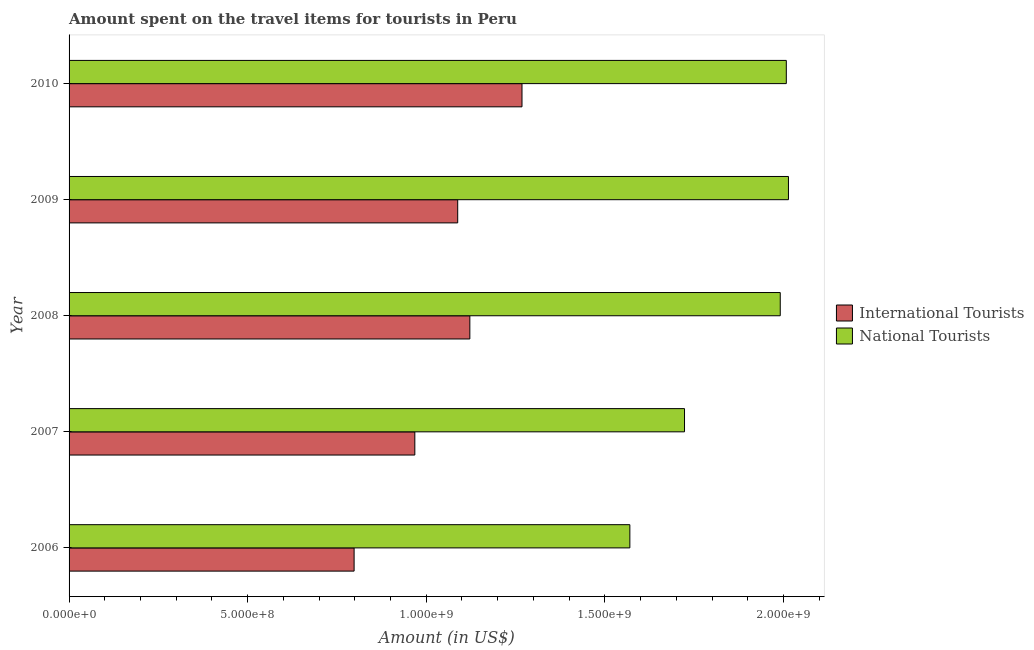How many different coloured bars are there?
Provide a short and direct response. 2. How many groups of bars are there?
Your response must be concise. 5. What is the amount spent on travel items of international tourists in 2009?
Your answer should be compact. 1.09e+09. Across all years, what is the maximum amount spent on travel items of international tourists?
Make the answer very short. 1.27e+09. Across all years, what is the minimum amount spent on travel items of national tourists?
Offer a very short reply. 1.57e+09. In which year was the amount spent on travel items of international tourists maximum?
Your response must be concise. 2010. What is the total amount spent on travel items of national tourists in the graph?
Give a very brief answer. 9.31e+09. What is the difference between the amount spent on travel items of national tourists in 2007 and that in 2008?
Offer a terse response. -2.68e+08. What is the difference between the amount spent on travel items of national tourists in 2010 and the amount spent on travel items of international tourists in 2006?
Your answer should be compact. 1.21e+09. What is the average amount spent on travel items of international tourists per year?
Give a very brief answer. 1.05e+09. In the year 2009, what is the difference between the amount spent on travel items of international tourists and amount spent on travel items of national tourists?
Your response must be concise. -9.26e+08. What is the ratio of the amount spent on travel items of international tourists in 2006 to that in 2007?
Make the answer very short. 0.82. Is the amount spent on travel items of international tourists in 2007 less than that in 2009?
Offer a very short reply. Yes. Is the difference between the amount spent on travel items of international tourists in 2006 and 2009 greater than the difference between the amount spent on travel items of national tourists in 2006 and 2009?
Offer a terse response. Yes. What is the difference between the highest and the second highest amount spent on travel items of national tourists?
Ensure brevity in your answer.  6.00e+06. What is the difference between the highest and the lowest amount spent on travel items of national tourists?
Make the answer very short. 4.44e+08. Is the sum of the amount spent on travel items of international tourists in 2007 and 2009 greater than the maximum amount spent on travel items of national tourists across all years?
Ensure brevity in your answer.  Yes. What does the 1st bar from the top in 2009 represents?
Provide a succinct answer. National Tourists. What does the 2nd bar from the bottom in 2010 represents?
Your answer should be very brief. National Tourists. How many bars are there?
Provide a short and direct response. 10. Does the graph contain grids?
Make the answer very short. No. What is the title of the graph?
Give a very brief answer. Amount spent on the travel items for tourists in Peru. What is the label or title of the Y-axis?
Keep it short and to the point. Year. What is the Amount (in US$) of International Tourists in 2006?
Provide a short and direct response. 7.98e+08. What is the Amount (in US$) of National Tourists in 2006?
Provide a short and direct response. 1.57e+09. What is the Amount (in US$) in International Tourists in 2007?
Make the answer very short. 9.68e+08. What is the Amount (in US$) of National Tourists in 2007?
Give a very brief answer. 1.72e+09. What is the Amount (in US$) of International Tourists in 2008?
Offer a terse response. 1.12e+09. What is the Amount (in US$) of National Tourists in 2008?
Your answer should be very brief. 1.99e+09. What is the Amount (in US$) in International Tourists in 2009?
Provide a short and direct response. 1.09e+09. What is the Amount (in US$) of National Tourists in 2009?
Your answer should be very brief. 2.01e+09. What is the Amount (in US$) in International Tourists in 2010?
Your answer should be very brief. 1.27e+09. What is the Amount (in US$) in National Tourists in 2010?
Your answer should be very brief. 2.01e+09. Across all years, what is the maximum Amount (in US$) in International Tourists?
Your response must be concise. 1.27e+09. Across all years, what is the maximum Amount (in US$) of National Tourists?
Make the answer very short. 2.01e+09. Across all years, what is the minimum Amount (in US$) of International Tourists?
Your answer should be very brief. 7.98e+08. Across all years, what is the minimum Amount (in US$) of National Tourists?
Offer a very short reply. 1.57e+09. What is the total Amount (in US$) in International Tourists in the graph?
Make the answer very short. 5.24e+09. What is the total Amount (in US$) in National Tourists in the graph?
Keep it short and to the point. 9.31e+09. What is the difference between the Amount (in US$) in International Tourists in 2006 and that in 2007?
Your answer should be very brief. -1.70e+08. What is the difference between the Amount (in US$) of National Tourists in 2006 and that in 2007?
Your response must be concise. -1.53e+08. What is the difference between the Amount (in US$) in International Tourists in 2006 and that in 2008?
Offer a very short reply. -3.24e+08. What is the difference between the Amount (in US$) in National Tourists in 2006 and that in 2008?
Make the answer very short. -4.21e+08. What is the difference between the Amount (in US$) of International Tourists in 2006 and that in 2009?
Give a very brief answer. -2.90e+08. What is the difference between the Amount (in US$) in National Tourists in 2006 and that in 2009?
Offer a terse response. -4.44e+08. What is the difference between the Amount (in US$) in International Tourists in 2006 and that in 2010?
Ensure brevity in your answer.  -4.70e+08. What is the difference between the Amount (in US$) in National Tourists in 2006 and that in 2010?
Ensure brevity in your answer.  -4.38e+08. What is the difference between the Amount (in US$) in International Tourists in 2007 and that in 2008?
Your answer should be compact. -1.54e+08. What is the difference between the Amount (in US$) of National Tourists in 2007 and that in 2008?
Provide a short and direct response. -2.68e+08. What is the difference between the Amount (in US$) of International Tourists in 2007 and that in 2009?
Provide a short and direct response. -1.20e+08. What is the difference between the Amount (in US$) in National Tourists in 2007 and that in 2009?
Keep it short and to the point. -2.91e+08. What is the difference between the Amount (in US$) of International Tourists in 2007 and that in 2010?
Give a very brief answer. -3.00e+08. What is the difference between the Amount (in US$) of National Tourists in 2007 and that in 2010?
Offer a very short reply. -2.85e+08. What is the difference between the Amount (in US$) of International Tourists in 2008 and that in 2009?
Provide a short and direct response. 3.40e+07. What is the difference between the Amount (in US$) in National Tourists in 2008 and that in 2009?
Provide a succinct answer. -2.30e+07. What is the difference between the Amount (in US$) in International Tourists in 2008 and that in 2010?
Offer a terse response. -1.46e+08. What is the difference between the Amount (in US$) in National Tourists in 2008 and that in 2010?
Provide a short and direct response. -1.70e+07. What is the difference between the Amount (in US$) of International Tourists in 2009 and that in 2010?
Provide a short and direct response. -1.80e+08. What is the difference between the Amount (in US$) of National Tourists in 2009 and that in 2010?
Your answer should be very brief. 6.00e+06. What is the difference between the Amount (in US$) in International Tourists in 2006 and the Amount (in US$) in National Tourists in 2007?
Offer a terse response. -9.25e+08. What is the difference between the Amount (in US$) in International Tourists in 2006 and the Amount (in US$) in National Tourists in 2008?
Ensure brevity in your answer.  -1.19e+09. What is the difference between the Amount (in US$) of International Tourists in 2006 and the Amount (in US$) of National Tourists in 2009?
Your answer should be compact. -1.22e+09. What is the difference between the Amount (in US$) of International Tourists in 2006 and the Amount (in US$) of National Tourists in 2010?
Make the answer very short. -1.21e+09. What is the difference between the Amount (in US$) of International Tourists in 2007 and the Amount (in US$) of National Tourists in 2008?
Make the answer very short. -1.02e+09. What is the difference between the Amount (in US$) in International Tourists in 2007 and the Amount (in US$) in National Tourists in 2009?
Give a very brief answer. -1.05e+09. What is the difference between the Amount (in US$) in International Tourists in 2007 and the Amount (in US$) in National Tourists in 2010?
Ensure brevity in your answer.  -1.04e+09. What is the difference between the Amount (in US$) in International Tourists in 2008 and the Amount (in US$) in National Tourists in 2009?
Your answer should be compact. -8.92e+08. What is the difference between the Amount (in US$) in International Tourists in 2008 and the Amount (in US$) in National Tourists in 2010?
Provide a short and direct response. -8.86e+08. What is the difference between the Amount (in US$) in International Tourists in 2009 and the Amount (in US$) in National Tourists in 2010?
Your answer should be compact. -9.20e+08. What is the average Amount (in US$) in International Tourists per year?
Offer a terse response. 1.05e+09. What is the average Amount (in US$) in National Tourists per year?
Provide a succinct answer. 1.86e+09. In the year 2006, what is the difference between the Amount (in US$) in International Tourists and Amount (in US$) in National Tourists?
Offer a terse response. -7.72e+08. In the year 2007, what is the difference between the Amount (in US$) in International Tourists and Amount (in US$) in National Tourists?
Keep it short and to the point. -7.55e+08. In the year 2008, what is the difference between the Amount (in US$) of International Tourists and Amount (in US$) of National Tourists?
Keep it short and to the point. -8.69e+08. In the year 2009, what is the difference between the Amount (in US$) in International Tourists and Amount (in US$) in National Tourists?
Provide a succinct answer. -9.26e+08. In the year 2010, what is the difference between the Amount (in US$) in International Tourists and Amount (in US$) in National Tourists?
Ensure brevity in your answer.  -7.40e+08. What is the ratio of the Amount (in US$) in International Tourists in 2006 to that in 2007?
Ensure brevity in your answer.  0.82. What is the ratio of the Amount (in US$) in National Tourists in 2006 to that in 2007?
Provide a short and direct response. 0.91. What is the ratio of the Amount (in US$) in International Tourists in 2006 to that in 2008?
Your answer should be compact. 0.71. What is the ratio of the Amount (in US$) in National Tourists in 2006 to that in 2008?
Your answer should be compact. 0.79. What is the ratio of the Amount (in US$) in International Tourists in 2006 to that in 2009?
Offer a very short reply. 0.73. What is the ratio of the Amount (in US$) in National Tourists in 2006 to that in 2009?
Offer a very short reply. 0.78. What is the ratio of the Amount (in US$) in International Tourists in 2006 to that in 2010?
Your answer should be very brief. 0.63. What is the ratio of the Amount (in US$) in National Tourists in 2006 to that in 2010?
Provide a short and direct response. 0.78. What is the ratio of the Amount (in US$) in International Tourists in 2007 to that in 2008?
Your answer should be very brief. 0.86. What is the ratio of the Amount (in US$) in National Tourists in 2007 to that in 2008?
Provide a succinct answer. 0.87. What is the ratio of the Amount (in US$) in International Tourists in 2007 to that in 2009?
Ensure brevity in your answer.  0.89. What is the ratio of the Amount (in US$) of National Tourists in 2007 to that in 2009?
Provide a short and direct response. 0.86. What is the ratio of the Amount (in US$) in International Tourists in 2007 to that in 2010?
Keep it short and to the point. 0.76. What is the ratio of the Amount (in US$) of National Tourists in 2007 to that in 2010?
Give a very brief answer. 0.86. What is the ratio of the Amount (in US$) in International Tourists in 2008 to that in 2009?
Offer a very short reply. 1.03. What is the ratio of the Amount (in US$) of National Tourists in 2008 to that in 2009?
Provide a short and direct response. 0.99. What is the ratio of the Amount (in US$) in International Tourists in 2008 to that in 2010?
Your response must be concise. 0.88. What is the ratio of the Amount (in US$) in International Tourists in 2009 to that in 2010?
Your answer should be compact. 0.86. What is the ratio of the Amount (in US$) of National Tourists in 2009 to that in 2010?
Make the answer very short. 1. What is the difference between the highest and the second highest Amount (in US$) in International Tourists?
Offer a very short reply. 1.46e+08. What is the difference between the highest and the lowest Amount (in US$) in International Tourists?
Ensure brevity in your answer.  4.70e+08. What is the difference between the highest and the lowest Amount (in US$) in National Tourists?
Give a very brief answer. 4.44e+08. 